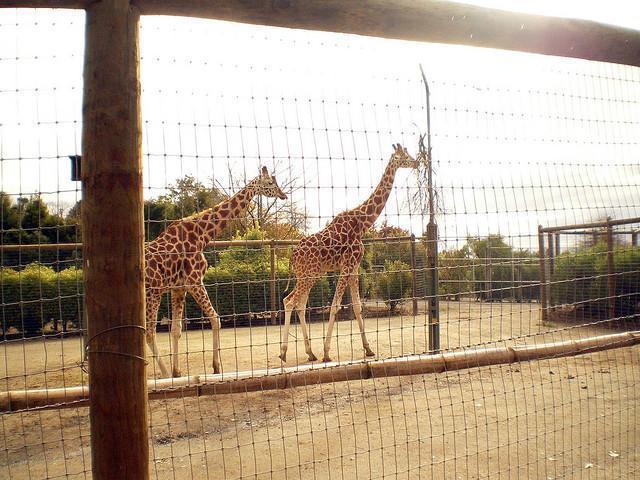How many animals are there?
Give a very brief answer. 2. How many giraffes are visible?
Give a very brief answer. 2. 